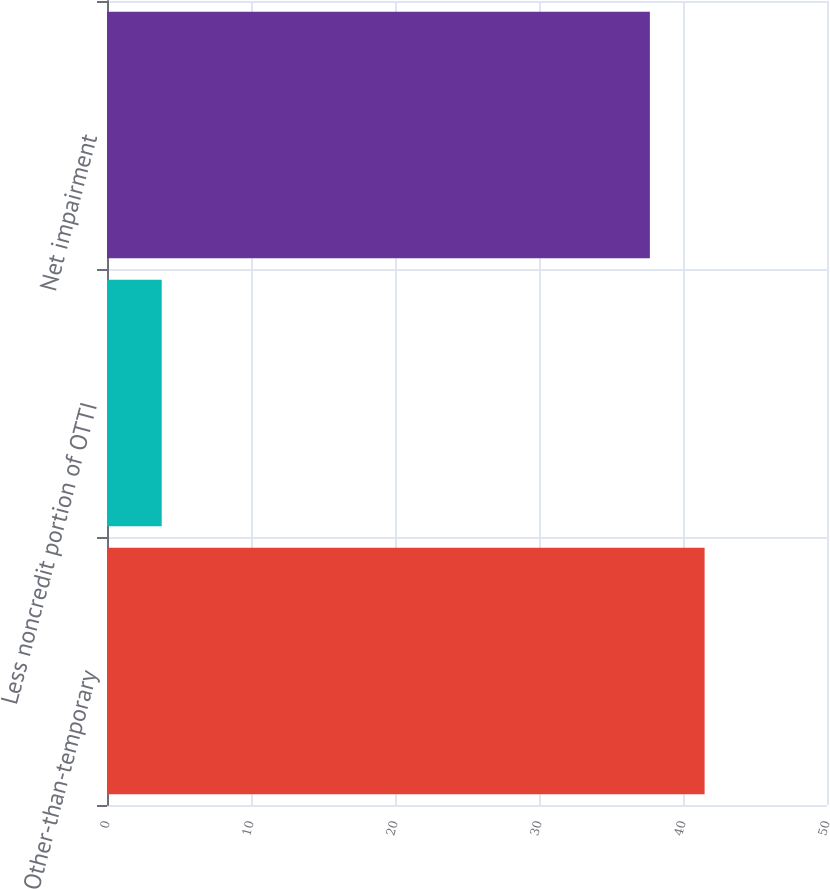<chart> <loc_0><loc_0><loc_500><loc_500><bar_chart><fcel>Other-than-temporary<fcel>Less noncredit portion of OTTI<fcel>Net impairment<nl><fcel>41.5<fcel>3.8<fcel>37.7<nl></chart> 